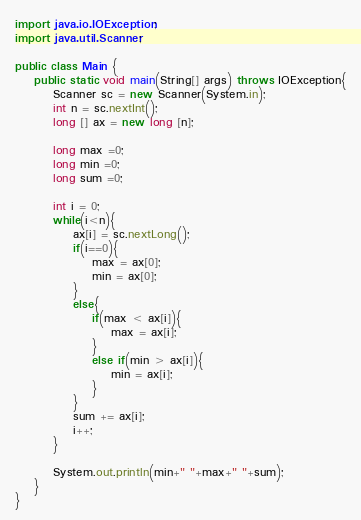Convert code to text. <code><loc_0><loc_0><loc_500><loc_500><_Java_>import java.io.IOException;
import java.util.Scanner;

public class Main {
	public static void main(String[] args) throws IOException{
		Scanner sc = new Scanner(System.in);
		int n = sc.nextInt();
		long [] ax = new long [n];
		
		long max =0;
		long min =0;
		long sum =0;
		
		int i = 0;
		while(i<n){
			ax[i] = sc.nextLong();
			if(i==0){
				max = ax[0];
				min = ax[0];
			}
			else{
				if(max < ax[i]){
					max = ax[i];
				}
				else if(min > ax[i]){
					min = ax[i];
				}
			}
			sum += ax[i];
			i++;
		}
		
		System.out.println(min+" "+max+" "+sum);
	}
}</code> 